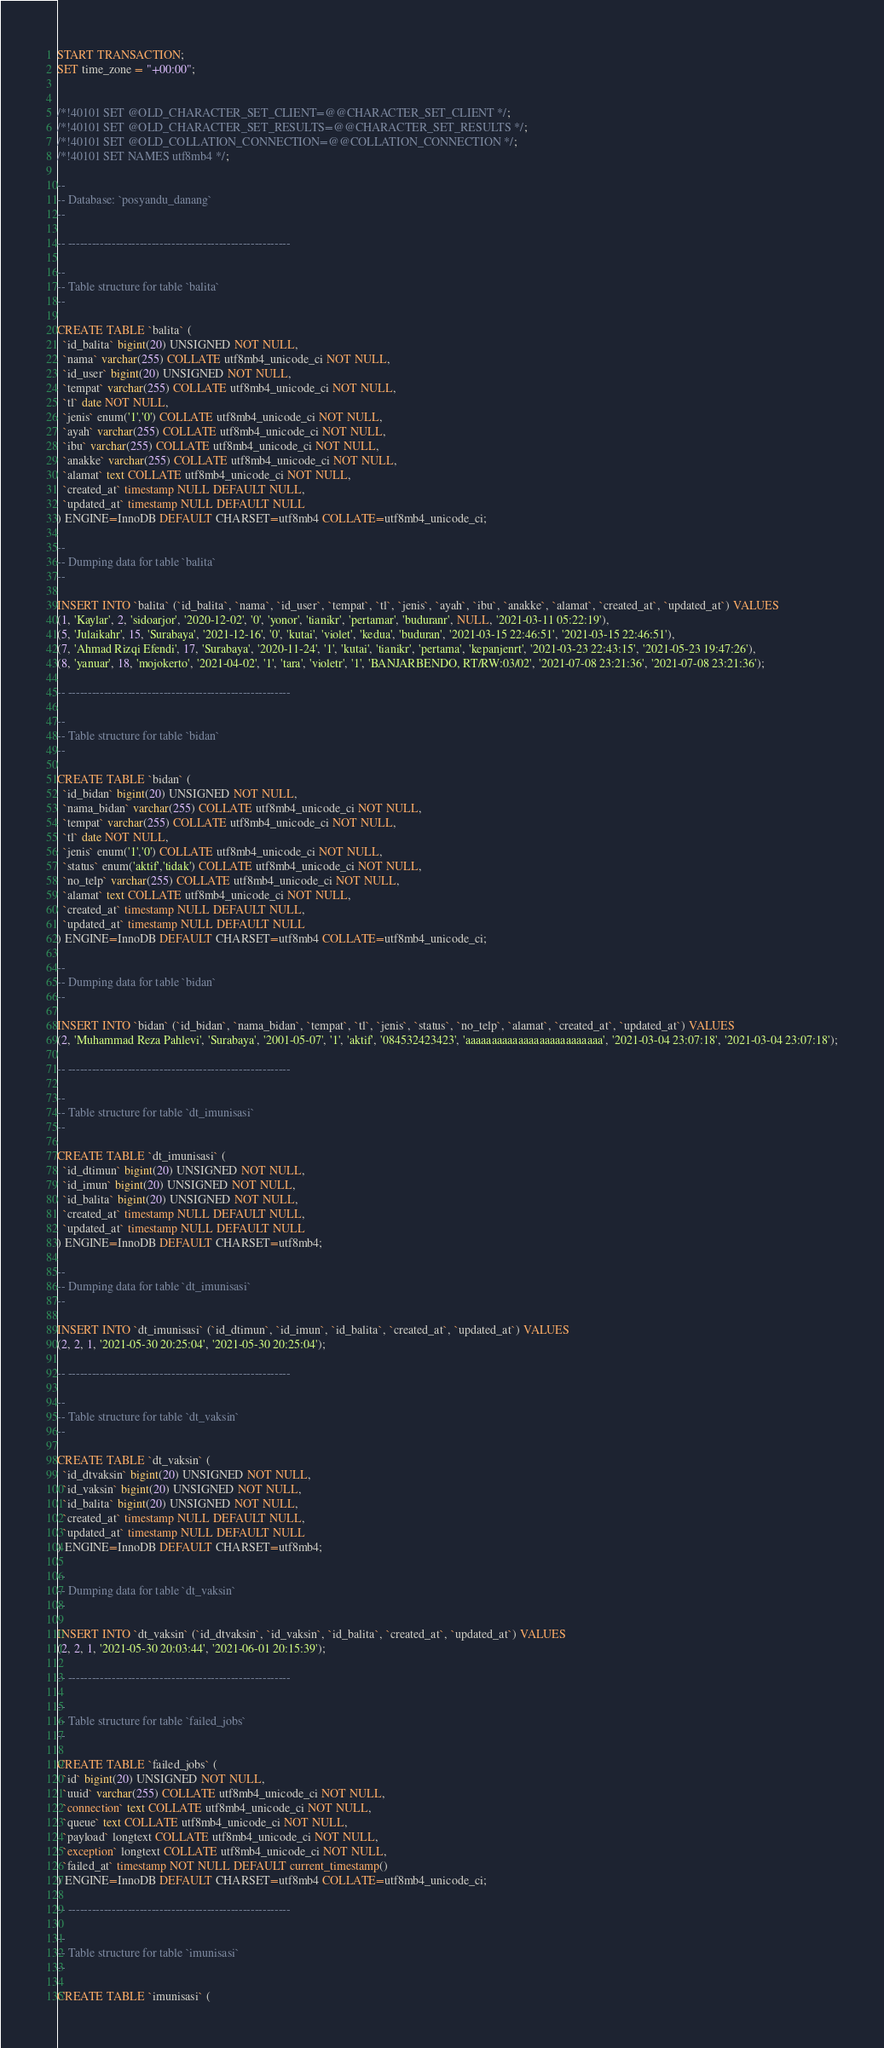<code> <loc_0><loc_0><loc_500><loc_500><_SQL_>START TRANSACTION;
SET time_zone = "+00:00";


/*!40101 SET @OLD_CHARACTER_SET_CLIENT=@@CHARACTER_SET_CLIENT */;
/*!40101 SET @OLD_CHARACTER_SET_RESULTS=@@CHARACTER_SET_RESULTS */;
/*!40101 SET @OLD_COLLATION_CONNECTION=@@COLLATION_CONNECTION */;
/*!40101 SET NAMES utf8mb4 */;

--
-- Database: `posyandu_danang`
--

-- --------------------------------------------------------

--
-- Table structure for table `balita`
--

CREATE TABLE `balita` (
  `id_balita` bigint(20) UNSIGNED NOT NULL,
  `nama` varchar(255) COLLATE utf8mb4_unicode_ci NOT NULL,
  `id_user` bigint(20) UNSIGNED NOT NULL,
  `tempat` varchar(255) COLLATE utf8mb4_unicode_ci NOT NULL,
  `tl` date NOT NULL,
  `jenis` enum('1','0') COLLATE utf8mb4_unicode_ci NOT NULL,
  `ayah` varchar(255) COLLATE utf8mb4_unicode_ci NOT NULL,
  `ibu` varchar(255) COLLATE utf8mb4_unicode_ci NOT NULL,
  `anakke` varchar(255) COLLATE utf8mb4_unicode_ci NOT NULL,
  `alamat` text COLLATE utf8mb4_unicode_ci NOT NULL,
  `created_at` timestamp NULL DEFAULT NULL,
  `updated_at` timestamp NULL DEFAULT NULL
) ENGINE=InnoDB DEFAULT CHARSET=utf8mb4 COLLATE=utf8mb4_unicode_ci;

--
-- Dumping data for table `balita`
--

INSERT INTO `balita` (`id_balita`, `nama`, `id_user`, `tempat`, `tl`, `jenis`, `ayah`, `ibu`, `anakke`, `alamat`, `created_at`, `updated_at`) VALUES
(1, 'Kaylar', 2, 'sidoarjor', '2020-12-02', '0', 'yonor', 'tianikr', 'pertamar', 'buduranr', NULL, '2021-03-11 05:22:19'),
(5, 'Julaikahr', 15, 'Surabaya', '2021-12-16', '0', 'kutai', 'violet', 'kedua', 'buduran', '2021-03-15 22:46:51', '2021-03-15 22:46:51'),
(7, 'Ahmad Rizqi Efendi', 17, 'Surabaya', '2020-11-24', '1', 'kutai', 'tianikr', 'pertama', 'kepanjenrt', '2021-03-23 22:43:15', '2021-05-23 19:47:26'),
(8, 'yanuar', 18, 'mojokerto', '2021-04-02', '1', 'tara', 'violetr', '1', 'BANJARBENDO, RT/RW:03/02', '2021-07-08 23:21:36', '2021-07-08 23:21:36');

-- --------------------------------------------------------

--
-- Table structure for table `bidan`
--

CREATE TABLE `bidan` (
  `id_bidan` bigint(20) UNSIGNED NOT NULL,
  `nama_bidan` varchar(255) COLLATE utf8mb4_unicode_ci NOT NULL,
  `tempat` varchar(255) COLLATE utf8mb4_unicode_ci NOT NULL,
  `tl` date NOT NULL,
  `jenis` enum('1','0') COLLATE utf8mb4_unicode_ci NOT NULL,
  `status` enum('aktif','tidak') COLLATE utf8mb4_unicode_ci NOT NULL,
  `no_telp` varchar(255) COLLATE utf8mb4_unicode_ci NOT NULL,
  `alamat` text COLLATE utf8mb4_unicode_ci NOT NULL,
  `created_at` timestamp NULL DEFAULT NULL,
  `updated_at` timestamp NULL DEFAULT NULL
) ENGINE=InnoDB DEFAULT CHARSET=utf8mb4 COLLATE=utf8mb4_unicode_ci;

--
-- Dumping data for table `bidan`
--

INSERT INTO `bidan` (`id_bidan`, `nama_bidan`, `tempat`, `tl`, `jenis`, `status`, `no_telp`, `alamat`, `created_at`, `updated_at`) VALUES
(2, 'Muhammad Reza Pahlevi', 'Surabaya', '2001-05-07', '1', 'aktif', '084532423423', 'aaaaaaaaaaaaaaaaaaaaaaaaaa', '2021-03-04 23:07:18', '2021-03-04 23:07:18');

-- --------------------------------------------------------

--
-- Table structure for table `dt_imunisasi`
--

CREATE TABLE `dt_imunisasi` (
  `id_dtimun` bigint(20) UNSIGNED NOT NULL,
  `id_imun` bigint(20) UNSIGNED NOT NULL,
  `id_balita` bigint(20) UNSIGNED NOT NULL,
  `created_at` timestamp NULL DEFAULT NULL,
  `updated_at` timestamp NULL DEFAULT NULL
) ENGINE=InnoDB DEFAULT CHARSET=utf8mb4;

--
-- Dumping data for table `dt_imunisasi`
--

INSERT INTO `dt_imunisasi` (`id_dtimun`, `id_imun`, `id_balita`, `created_at`, `updated_at`) VALUES
(2, 2, 1, '2021-05-30 20:25:04', '2021-05-30 20:25:04');

-- --------------------------------------------------------

--
-- Table structure for table `dt_vaksin`
--

CREATE TABLE `dt_vaksin` (
  `id_dtvaksin` bigint(20) UNSIGNED NOT NULL,
  `id_vaksin` bigint(20) UNSIGNED NOT NULL,
  `id_balita` bigint(20) UNSIGNED NOT NULL,
  `created_at` timestamp NULL DEFAULT NULL,
  `updated_at` timestamp NULL DEFAULT NULL
) ENGINE=InnoDB DEFAULT CHARSET=utf8mb4;

--
-- Dumping data for table `dt_vaksin`
--

INSERT INTO `dt_vaksin` (`id_dtvaksin`, `id_vaksin`, `id_balita`, `created_at`, `updated_at`) VALUES
(2, 2, 1, '2021-05-30 20:03:44', '2021-06-01 20:15:39');

-- --------------------------------------------------------

--
-- Table structure for table `failed_jobs`
--

CREATE TABLE `failed_jobs` (
  `id` bigint(20) UNSIGNED NOT NULL,
  `uuid` varchar(255) COLLATE utf8mb4_unicode_ci NOT NULL,
  `connection` text COLLATE utf8mb4_unicode_ci NOT NULL,
  `queue` text COLLATE utf8mb4_unicode_ci NOT NULL,
  `payload` longtext COLLATE utf8mb4_unicode_ci NOT NULL,
  `exception` longtext COLLATE utf8mb4_unicode_ci NOT NULL,
  `failed_at` timestamp NOT NULL DEFAULT current_timestamp()
) ENGINE=InnoDB DEFAULT CHARSET=utf8mb4 COLLATE=utf8mb4_unicode_ci;

-- --------------------------------------------------------

--
-- Table structure for table `imunisasi`
--

CREATE TABLE `imunisasi` (</code> 